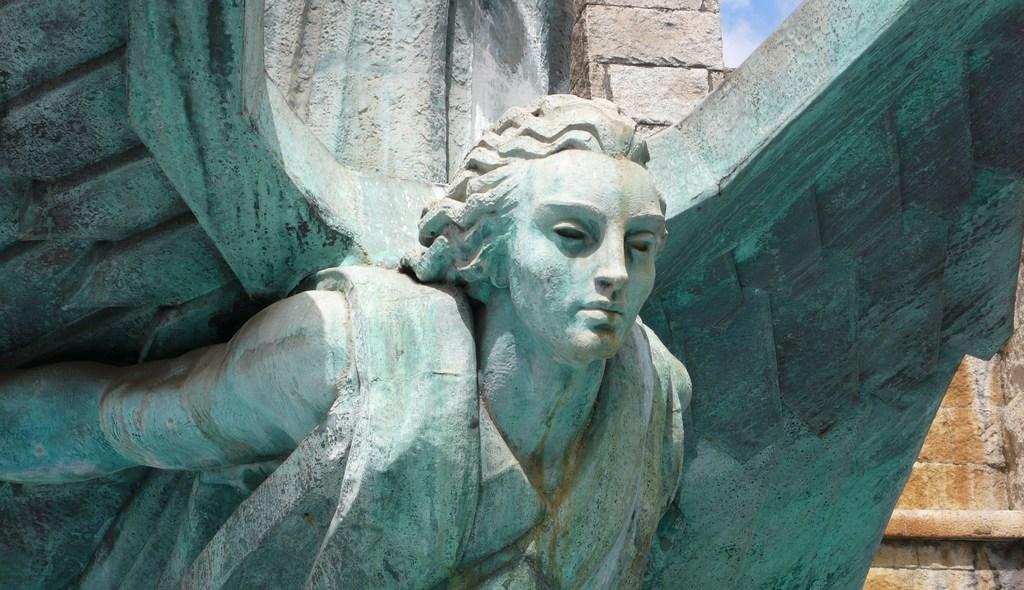In one or two sentences, can you explain what this image depicts? In this image I can see a sculpture which is in the shape of a person which is made of rock which is bluish white in color. In the background I can see the wall which is made of rocks and the sky. 